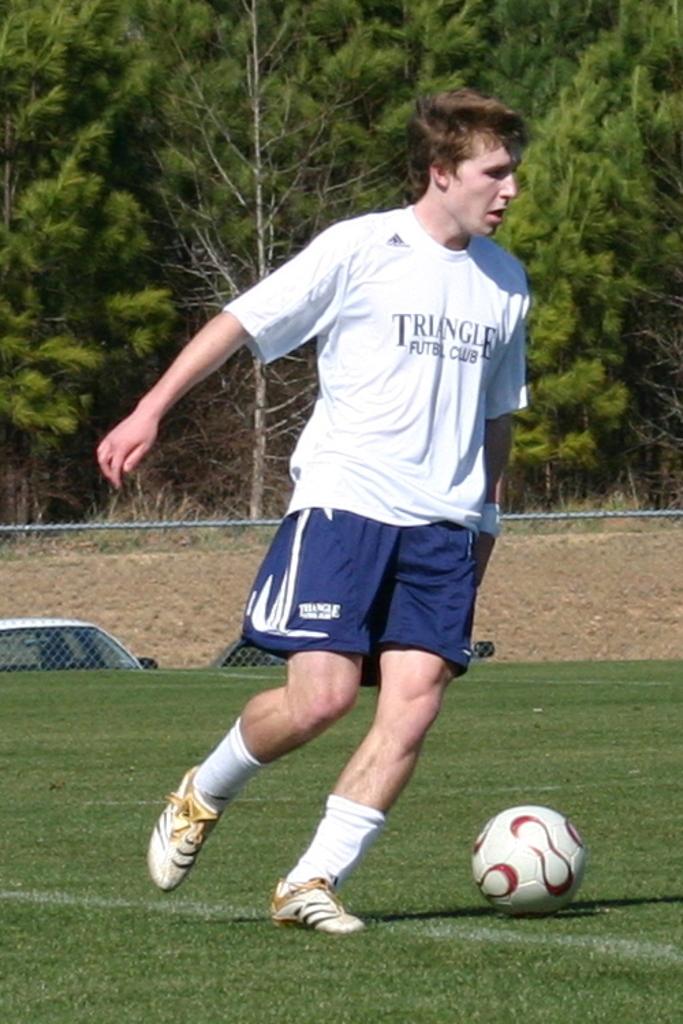Is the shirt from a futbol club?
Give a very brief answer. Yes. 